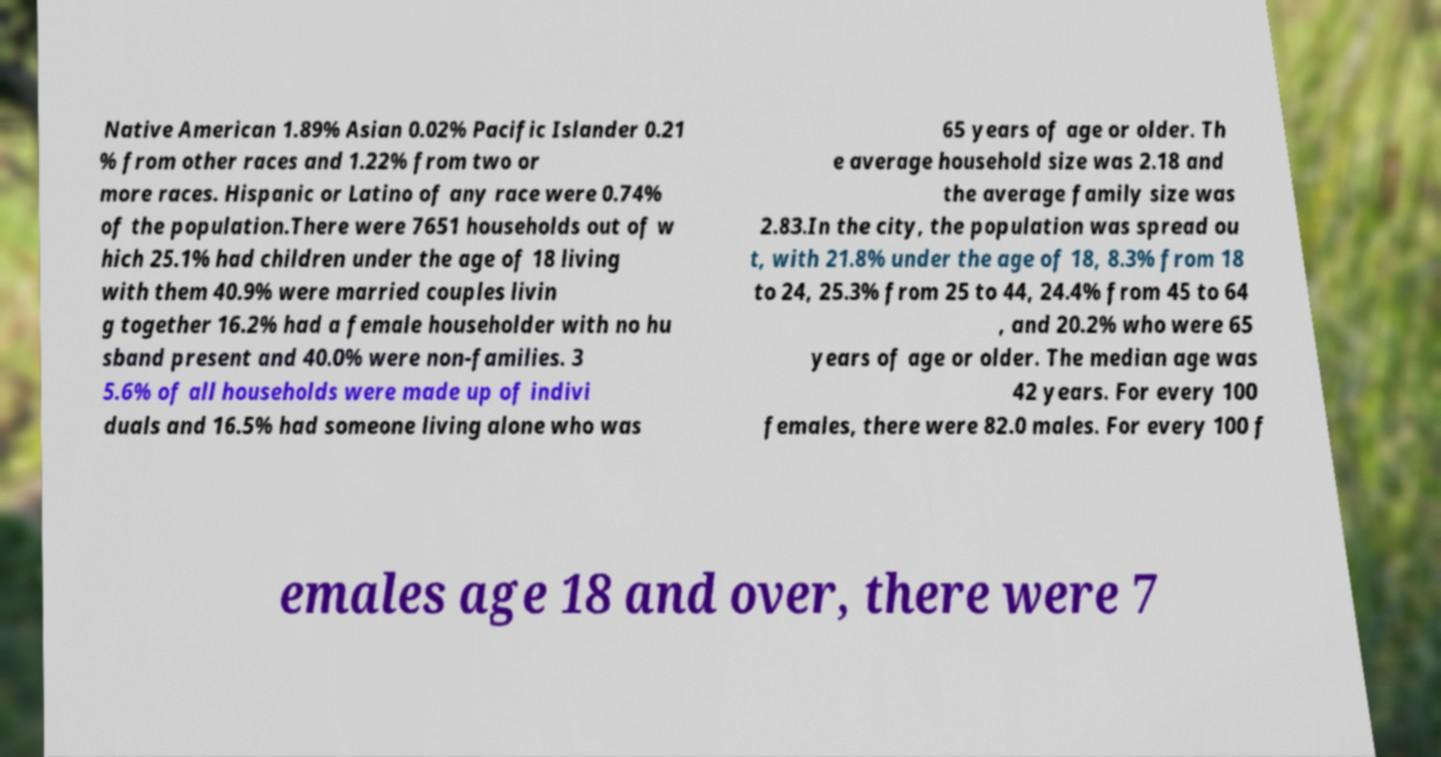What messages or text are displayed in this image? I need them in a readable, typed format. Native American 1.89% Asian 0.02% Pacific Islander 0.21 % from other races and 1.22% from two or more races. Hispanic or Latino of any race were 0.74% of the population.There were 7651 households out of w hich 25.1% had children under the age of 18 living with them 40.9% were married couples livin g together 16.2% had a female householder with no hu sband present and 40.0% were non-families. 3 5.6% of all households were made up of indivi duals and 16.5% had someone living alone who was 65 years of age or older. Th e average household size was 2.18 and the average family size was 2.83.In the city, the population was spread ou t, with 21.8% under the age of 18, 8.3% from 18 to 24, 25.3% from 25 to 44, 24.4% from 45 to 64 , and 20.2% who were 65 years of age or older. The median age was 42 years. For every 100 females, there were 82.0 males. For every 100 f emales age 18 and over, there were 7 